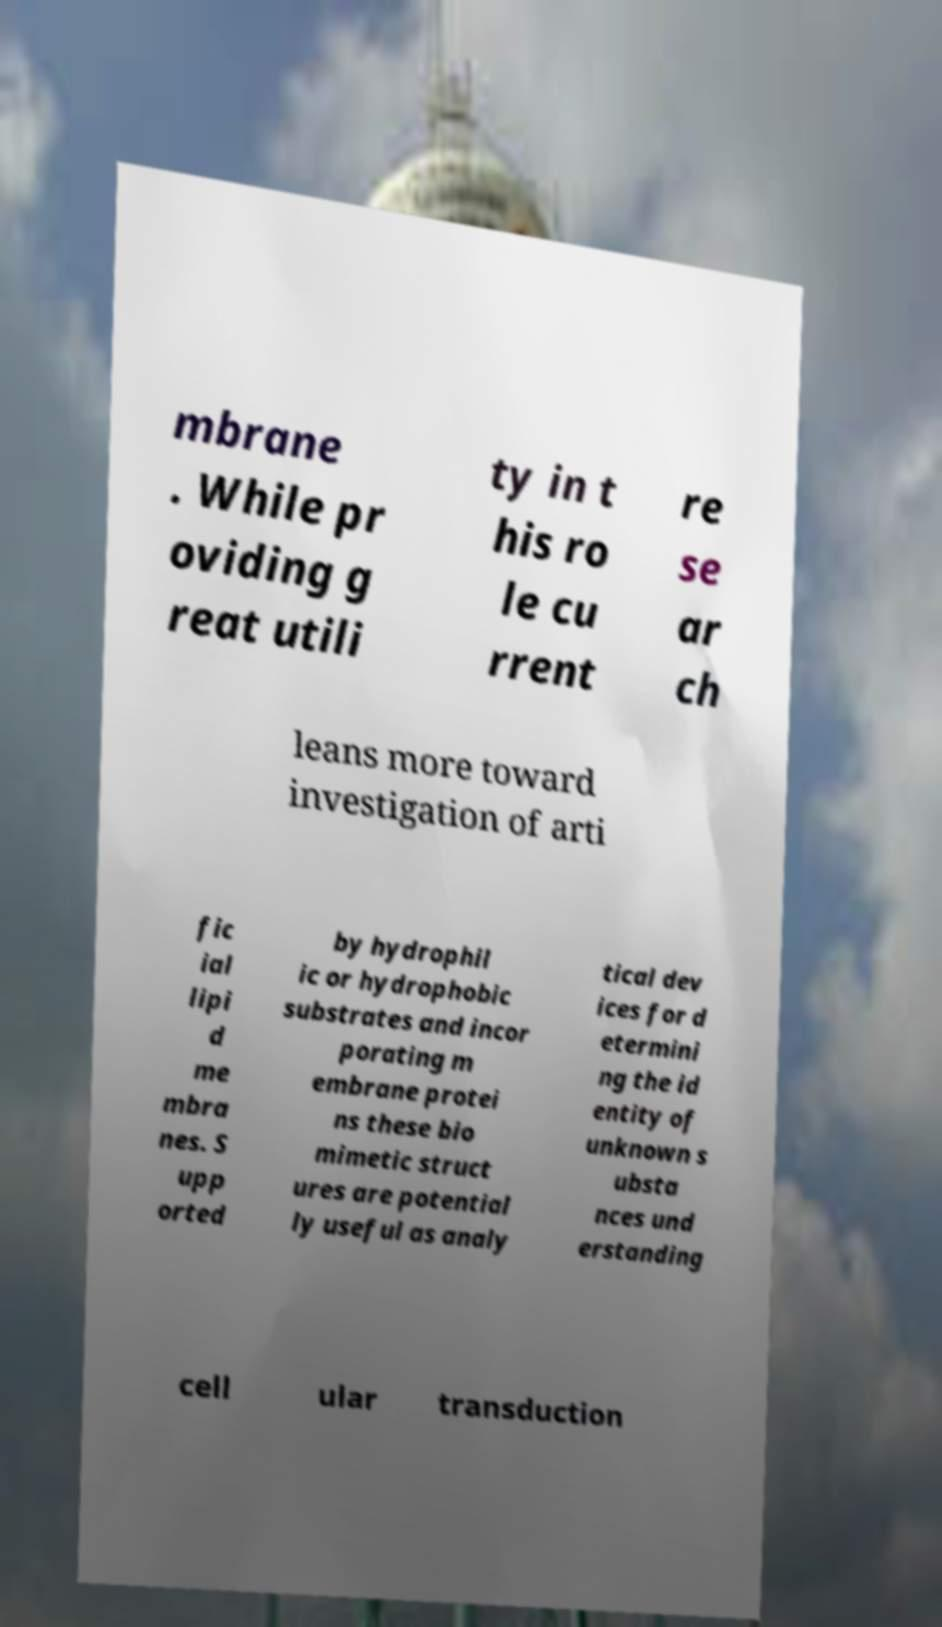There's text embedded in this image that I need extracted. Can you transcribe it verbatim? mbrane . While pr oviding g reat utili ty in t his ro le cu rrent re se ar ch leans more toward investigation of arti fic ial lipi d me mbra nes. S upp orted by hydrophil ic or hydrophobic substrates and incor porating m embrane protei ns these bio mimetic struct ures are potential ly useful as analy tical dev ices for d etermini ng the id entity of unknown s ubsta nces und erstanding cell ular transduction 